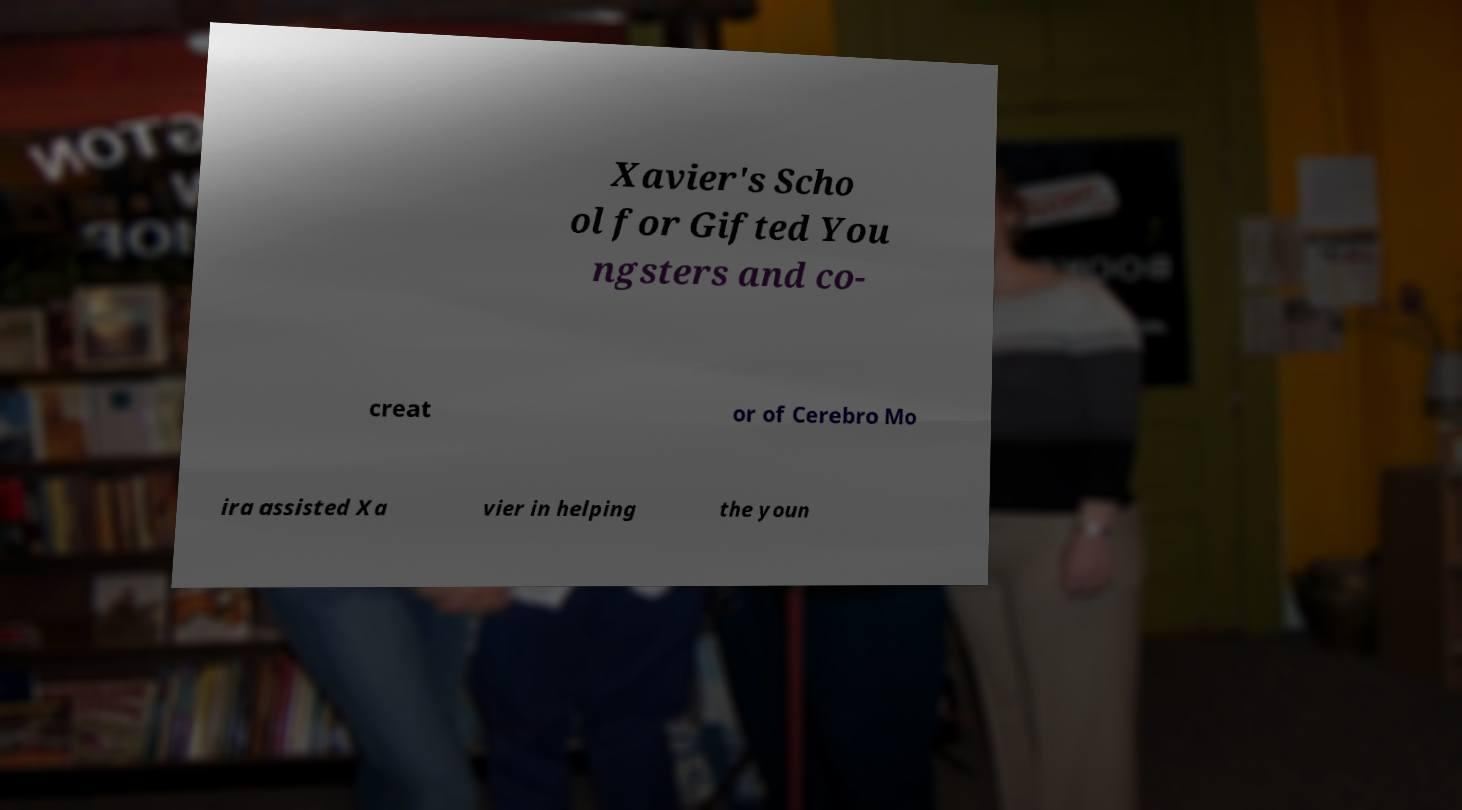Could you extract and type out the text from this image? Xavier's Scho ol for Gifted You ngsters and co- creat or of Cerebro Mo ira assisted Xa vier in helping the youn 